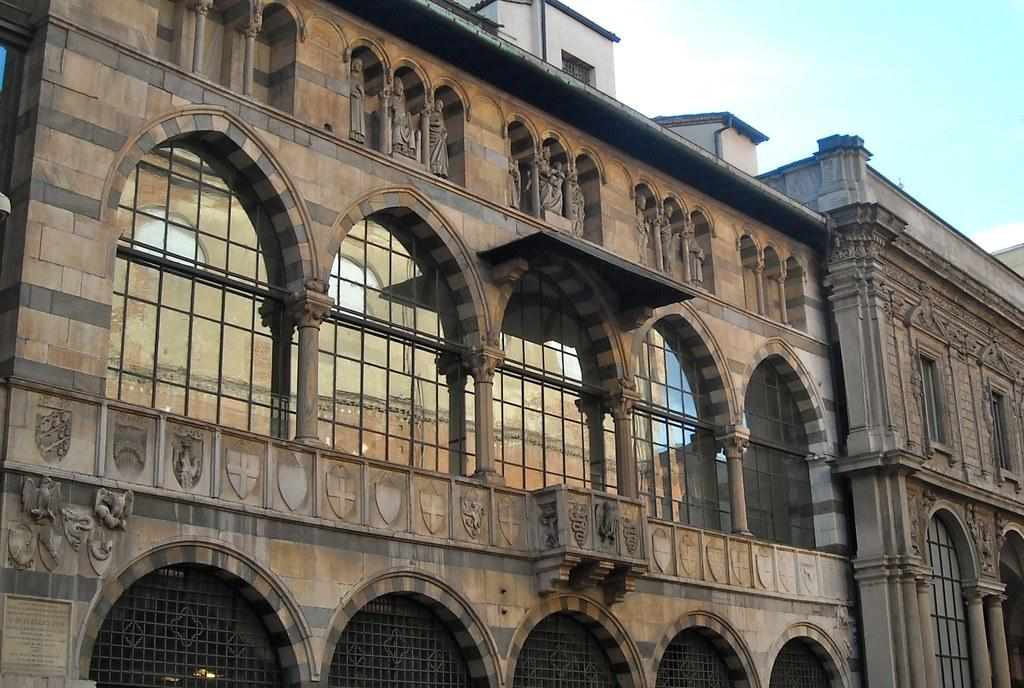What type of structure is visible in the image? There is a building in the image. Are there any specific features of the building that can be seen? Yes, there is a window in the building. What is visible at the top of the image? The sky is visible at the top of the image. Can you see the crown on the king's head in the image? There is no king or crown present in the image; it features a building with a window and a visible sky. 